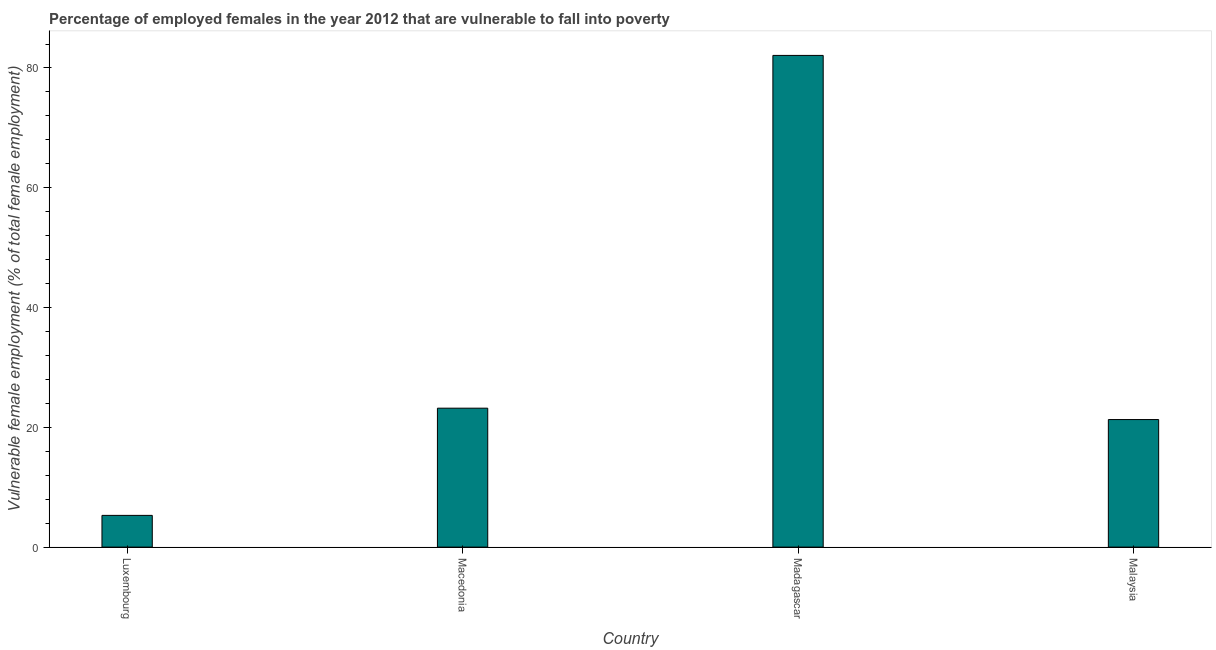Does the graph contain any zero values?
Your answer should be compact. No. Does the graph contain grids?
Your response must be concise. No. What is the title of the graph?
Ensure brevity in your answer.  Percentage of employed females in the year 2012 that are vulnerable to fall into poverty. What is the label or title of the Y-axis?
Make the answer very short. Vulnerable female employment (% of total female employment). What is the percentage of employed females who are vulnerable to fall into poverty in Madagascar?
Your answer should be compact. 82.1. Across all countries, what is the maximum percentage of employed females who are vulnerable to fall into poverty?
Ensure brevity in your answer.  82.1. Across all countries, what is the minimum percentage of employed females who are vulnerable to fall into poverty?
Make the answer very short. 5.3. In which country was the percentage of employed females who are vulnerable to fall into poverty maximum?
Your answer should be compact. Madagascar. In which country was the percentage of employed females who are vulnerable to fall into poverty minimum?
Your answer should be compact. Luxembourg. What is the sum of the percentage of employed females who are vulnerable to fall into poverty?
Give a very brief answer. 131.9. What is the average percentage of employed females who are vulnerable to fall into poverty per country?
Keep it short and to the point. 32.98. What is the median percentage of employed females who are vulnerable to fall into poverty?
Provide a succinct answer. 22.25. What is the ratio of the percentage of employed females who are vulnerable to fall into poverty in Madagascar to that in Malaysia?
Offer a very short reply. 3.85. Is the difference between the percentage of employed females who are vulnerable to fall into poverty in Luxembourg and Madagascar greater than the difference between any two countries?
Your answer should be compact. Yes. What is the difference between the highest and the second highest percentage of employed females who are vulnerable to fall into poverty?
Keep it short and to the point. 58.9. What is the difference between the highest and the lowest percentage of employed females who are vulnerable to fall into poverty?
Offer a terse response. 76.8. How many bars are there?
Keep it short and to the point. 4. Are all the bars in the graph horizontal?
Your answer should be very brief. No. How many countries are there in the graph?
Ensure brevity in your answer.  4. What is the difference between two consecutive major ticks on the Y-axis?
Your answer should be compact. 20. What is the Vulnerable female employment (% of total female employment) in Luxembourg?
Your answer should be compact. 5.3. What is the Vulnerable female employment (% of total female employment) in Macedonia?
Offer a very short reply. 23.2. What is the Vulnerable female employment (% of total female employment) of Madagascar?
Provide a succinct answer. 82.1. What is the Vulnerable female employment (% of total female employment) in Malaysia?
Your answer should be very brief. 21.3. What is the difference between the Vulnerable female employment (% of total female employment) in Luxembourg and Macedonia?
Give a very brief answer. -17.9. What is the difference between the Vulnerable female employment (% of total female employment) in Luxembourg and Madagascar?
Ensure brevity in your answer.  -76.8. What is the difference between the Vulnerable female employment (% of total female employment) in Macedonia and Madagascar?
Your answer should be very brief. -58.9. What is the difference between the Vulnerable female employment (% of total female employment) in Madagascar and Malaysia?
Make the answer very short. 60.8. What is the ratio of the Vulnerable female employment (% of total female employment) in Luxembourg to that in Macedonia?
Your answer should be compact. 0.23. What is the ratio of the Vulnerable female employment (% of total female employment) in Luxembourg to that in Madagascar?
Provide a short and direct response. 0.07. What is the ratio of the Vulnerable female employment (% of total female employment) in Luxembourg to that in Malaysia?
Your response must be concise. 0.25. What is the ratio of the Vulnerable female employment (% of total female employment) in Macedonia to that in Madagascar?
Ensure brevity in your answer.  0.28. What is the ratio of the Vulnerable female employment (% of total female employment) in Macedonia to that in Malaysia?
Provide a short and direct response. 1.09. What is the ratio of the Vulnerable female employment (% of total female employment) in Madagascar to that in Malaysia?
Your answer should be very brief. 3.85. 